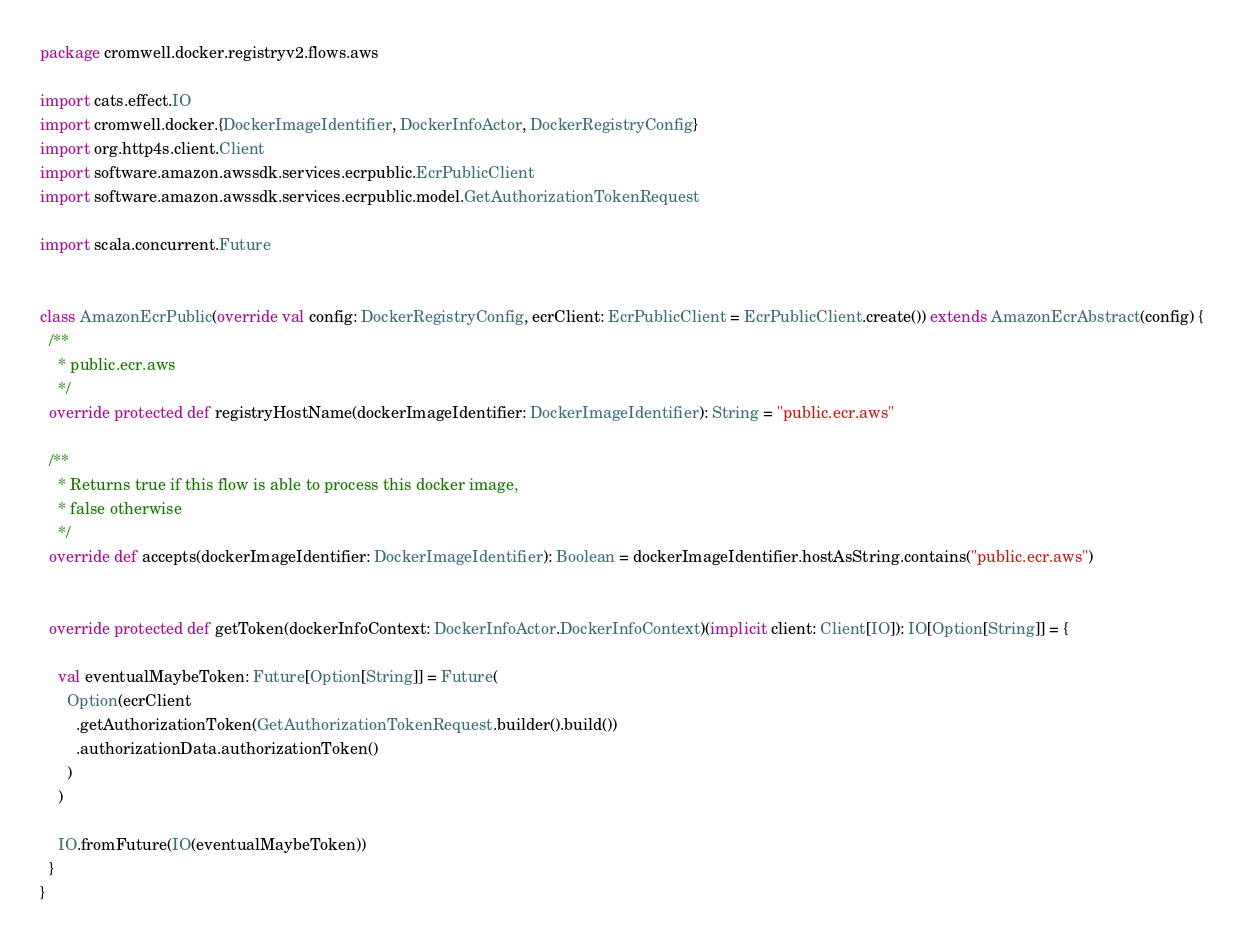<code> <loc_0><loc_0><loc_500><loc_500><_Scala_>package cromwell.docker.registryv2.flows.aws

import cats.effect.IO
import cromwell.docker.{DockerImageIdentifier, DockerInfoActor, DockerRegistryConfig}
import org.http4s.client.Client
import software.amazon.awssdk.services.ecrpublic.EcrPublicClient
import software.amazon.awssdk.services.ecrpublic.model.GetAuthorizationTokenRequest

import scala.concurrent.Future


class AmazonEcrPublic(override val config: DockerRegistryConfig, ecrClient: EcrPublicClient = EcrPublicClient.create()) extends AmazonEcrAbstract(config) {
  /**
    * public.ecr.aws
    */
  override protected def registryHostName(dockerImageIdentifier: DockerImageIdentifier): String = "public.ecr.aws"

  /**
    * Returns true if this flow is able to process this docker image,
    * false otherwise
    */
  override def accepts(dockerImageIdentifier: DockerImageIdentifier): Boolean = dockerImageIdentifier.hostAsString.contains("public.ecr.aws")


  override protected def getToken(dockerInfoContext: DockerInfoActor.DockerInfoContext)(implicit client: Client[IO]): IO[Option[String]] = {

    val eventualMaybeToken: Future[Option[String]] = Future(
      Option(ecrClient
        .getAuthorizationToken(GetAuthorizationTokenRequest.builder().build())
        .authorizationData.authorizationToken()
      )
    )

    IO.fromFuture(IO(eventualMaybeToken))
  }
}
</code> 